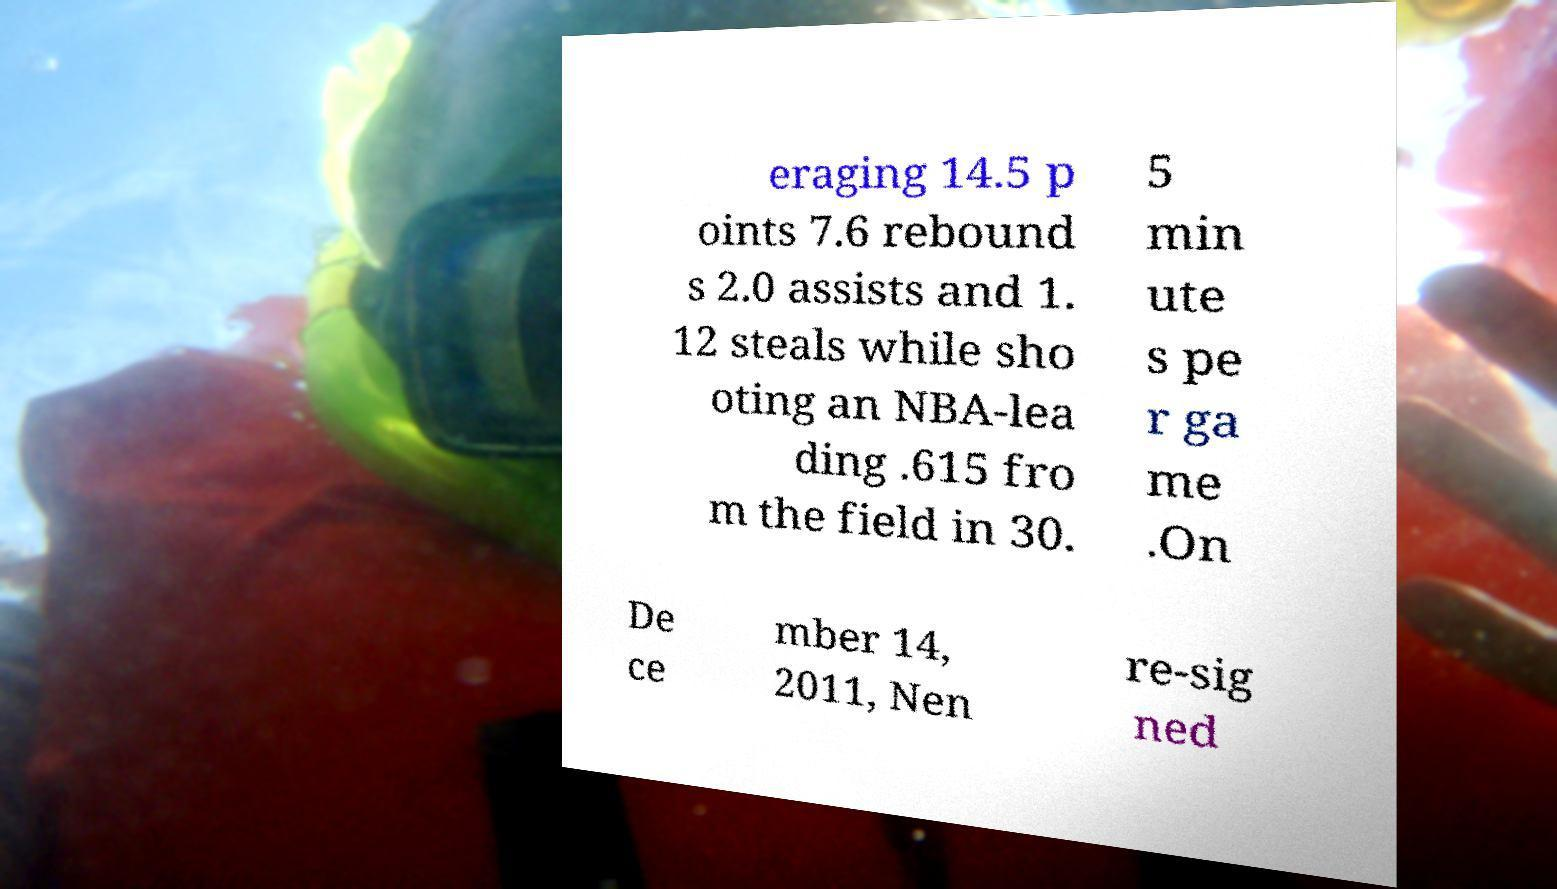I need the written content from this picture converted into text. Can you do that? eraging 14.5 p oints 7.6 rebound s 2.0 assists and 1. 12 steals while sho oting an NBA-lea ding .615 fro m the field in 30. 5 min ute s pe r ga me .On De ce mber 14, 2011, Nen re-sig ned 